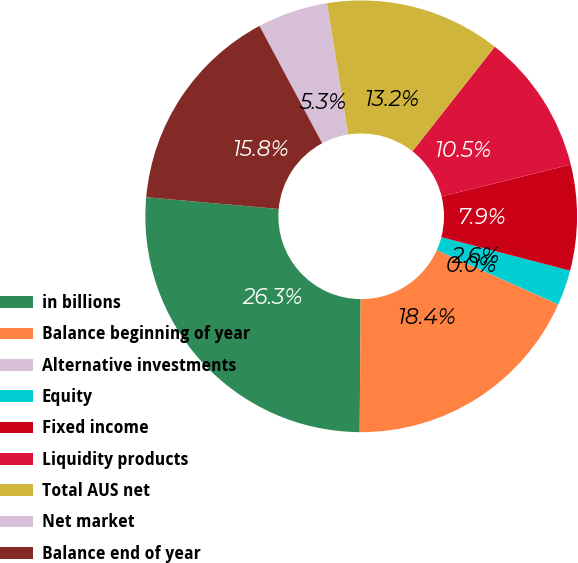Convert chart. <chart><loc_0><loc_0><loc_500><loc_500><pie_chart><fcel>in billions<fcel>Balance beginning of year<fcel>Alternative investments<fcel>Equity<fcel>Fixed income<fcel>Liquidity products<fcel>Total AUS net<fcel>Net market<fcel>Balance end of year<nl><fcel>26.3%<fcel>18.41%<fcel>0.01%<fcel>2.64%<fcel>7.9%<fcel>10.53%<fcel>13.16%<fcel>5.27%<fcel>15.78%<nl></chart> 